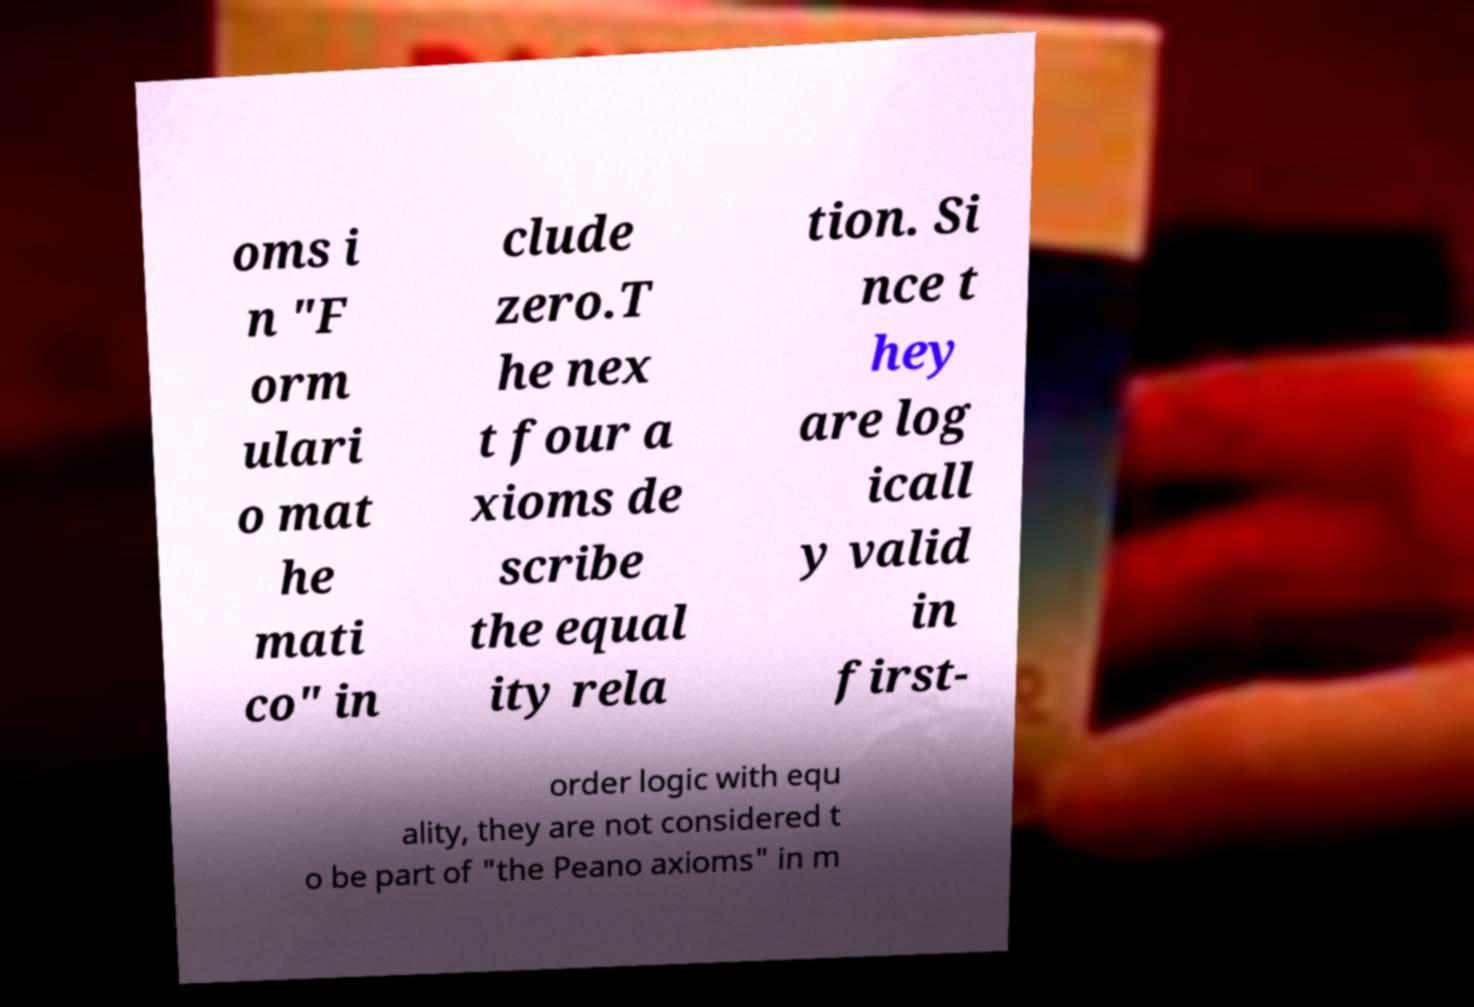Could you assist in decoding the text presented in this image and type it out clearly? oms i n "F orm ulari o mat he mati co" in clude zero.T he nex t four a xioms de scribe the equal ity rela tion. Si nce t hey are log icall y valid in first- order logic with equ ality, they are not considered t o be part of "the Peano axioms" in m 